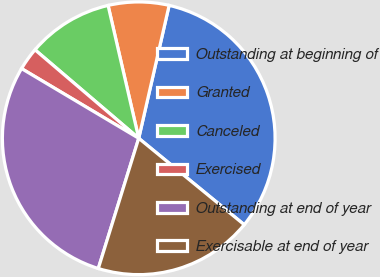Convert chart to OTSL. <chart><loc_0><loc_0><loc_500><loc_500><pie_chart><fcel>Outstanding at beginning of<fcel>Granted<fcel>Canceled<fcel>Exercised<fcel>Outstanding at end of year<fcel>Exercisable at end of year<nl><fcel>32.35%<fcel>7.19%<fcel>10.15%<fcel>2.7%<fcel>28.75%<fcel>18.87%<nl></chart> 